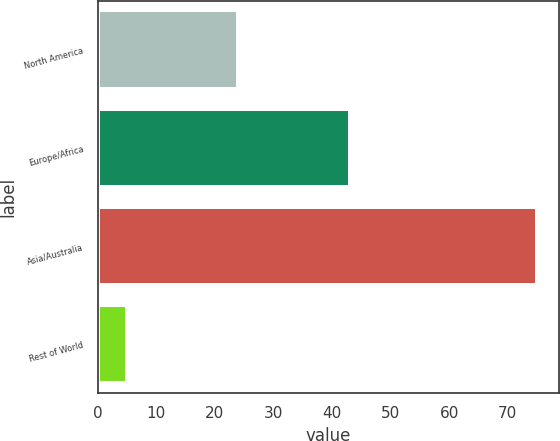Convert chart. <chart><loc_0><loc_0><loc_500><loc_500><bar_chart><fcel>North America<fcel>Europe/Africa<fcel>Asia/Australia<fcel>Rest of World<nl><fcel>24<fcel>43<fcel>75<fcel>5<nl></chart> 